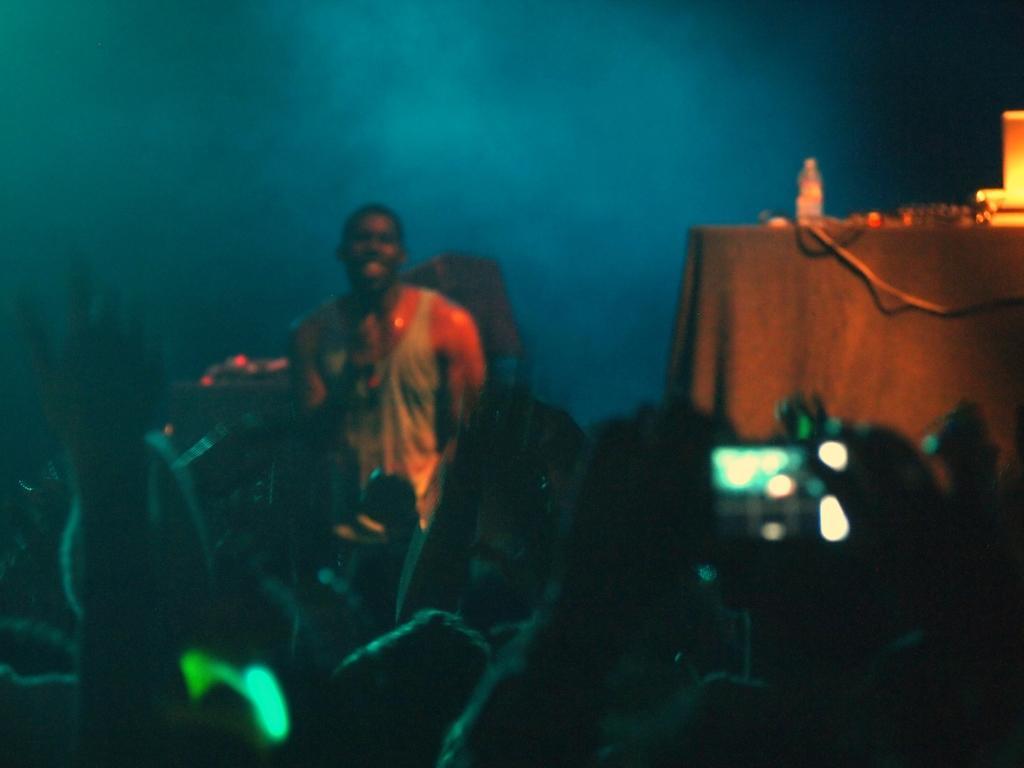How would you summarize this image in a sentence or two? In this image there are a few people raising their hands, a few are holding their mobiles in their hands, in front of them there is a person standing, beside a person there is a table with some objects and a bottle. The background is dark. 